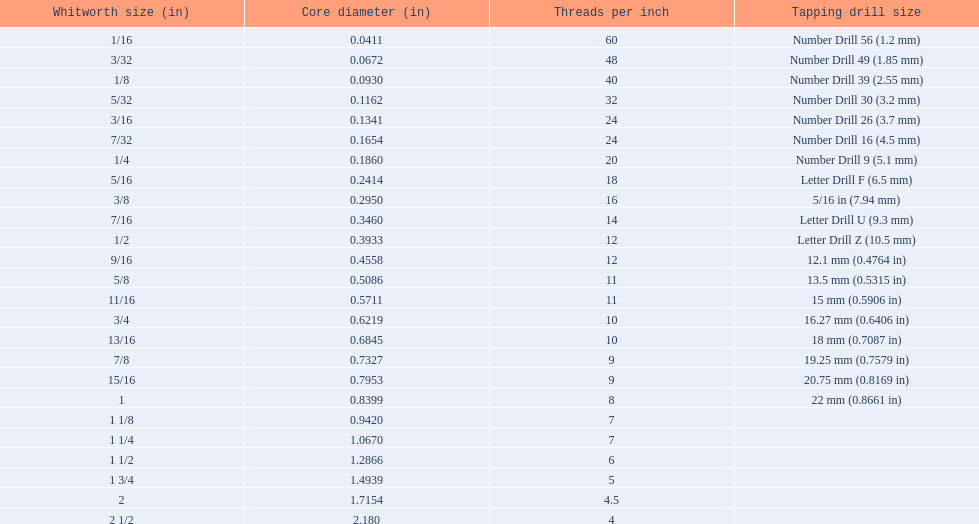What is the core diameter for the number drill 26? 0.1341. What is the whitworth size (in) for this core diameter? 3/16. 